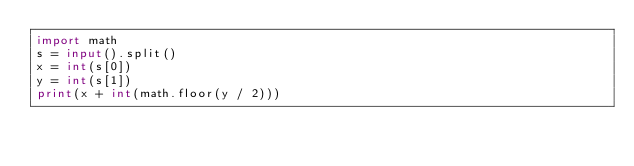Convert code to text. <code><loc_0><loc_0><loc_500><loc_500><_Python_>import math
s = input().split()
x = int(s[0])
y = int(s[1])
print(x + int(math.floor(y / 2)))</code> 